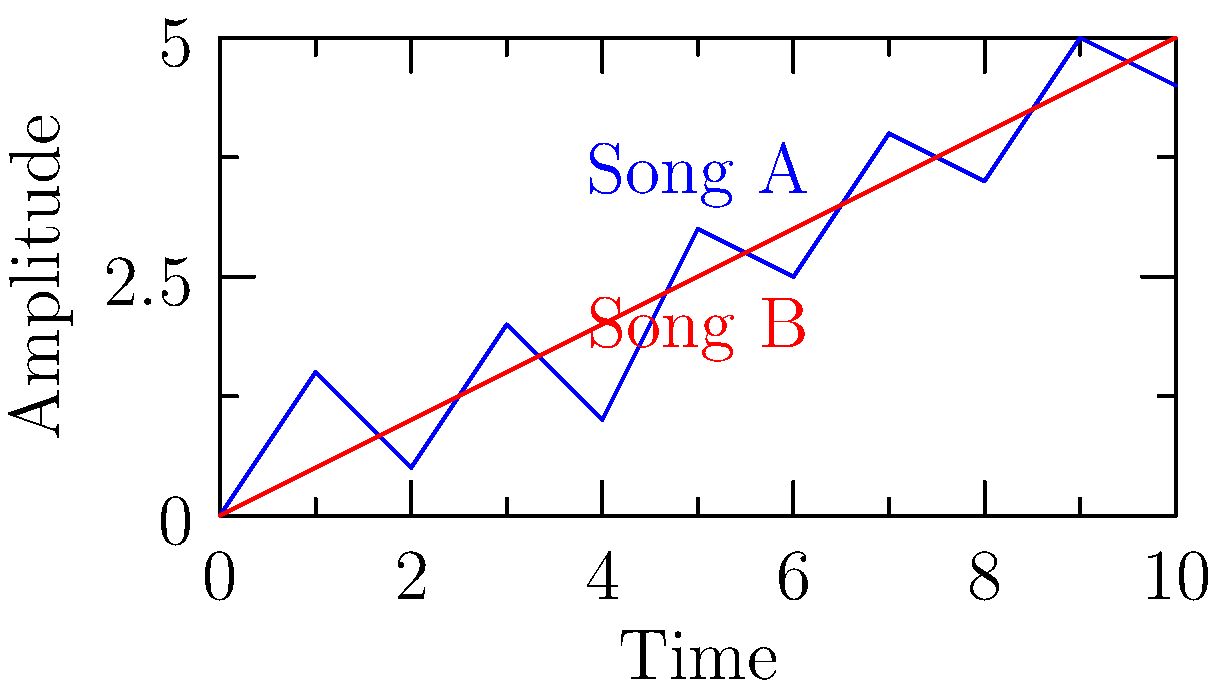As a record producer, you're analyzing the waveform visualizations of two songs to predict their potential popularity. Song A (blue) shows more variation in amplitude, while Song B (red) has a steadier, gradually increasing amplitude. Based on these waveforms, which song is more likely to become a hit and why? To answer this question, we need to analyze the characteristics of each waveform and their potential impact on song popularity:

1. Song A (blue):
   - Shows more variation in amplitude
   - Has peaks and valleys throughout the waveform
   - Indicates dynamic changes in the song's intensity

2. Song B (red):
   - Has a steadier, gradually increasing amplitude
   - Shows a more consistent progression
   - Lacks significant dynamic changes

3. Factors affecting song popularity:
   - Dynamic range: Songs with more variation in loudness and quietness tend to be more engaging
   - Emotional impact: Sudden changes in amplitude can create emotional responses in listeners
   - Memorability: Distinctive patterns in waveforms can make a song more memorable

4. Analysis:
   - Song A's varied waveform suggests more dynamic range, potentially creating a more engaging listening experience
   - The peaks and valleys in Song A's waveform may correspond to hooks or chorus sections, which are crucial for hit songs
   - Song B's steady progression might indicate a more ambient or background-friendly track, which may not grab listeners' attention as effectively

5. Conclusion:
   Based on the waveform analysis, Song A is more likely to become a hit due to its dynamic range, potential for emotional impact, and distinctive pattern that could make it more memorable and engaging for listeners.
Answer: Song A, due to its dynamic waveform indicating more engaging and memorable musical elements. 